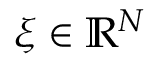<formula> <loc_0><loc_0><loc_500><loc_500>\xi \in \mathbb { R } ^ { N }</formula> 